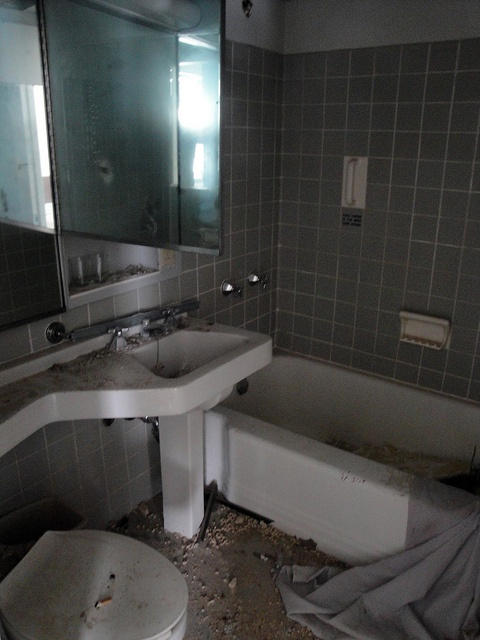Describe the objects in this image and their specific colors. I can see toilet in gray and black tones, sink in gray and black tones, cup in gray and black tones, and cup in gray and black tones in this image. 